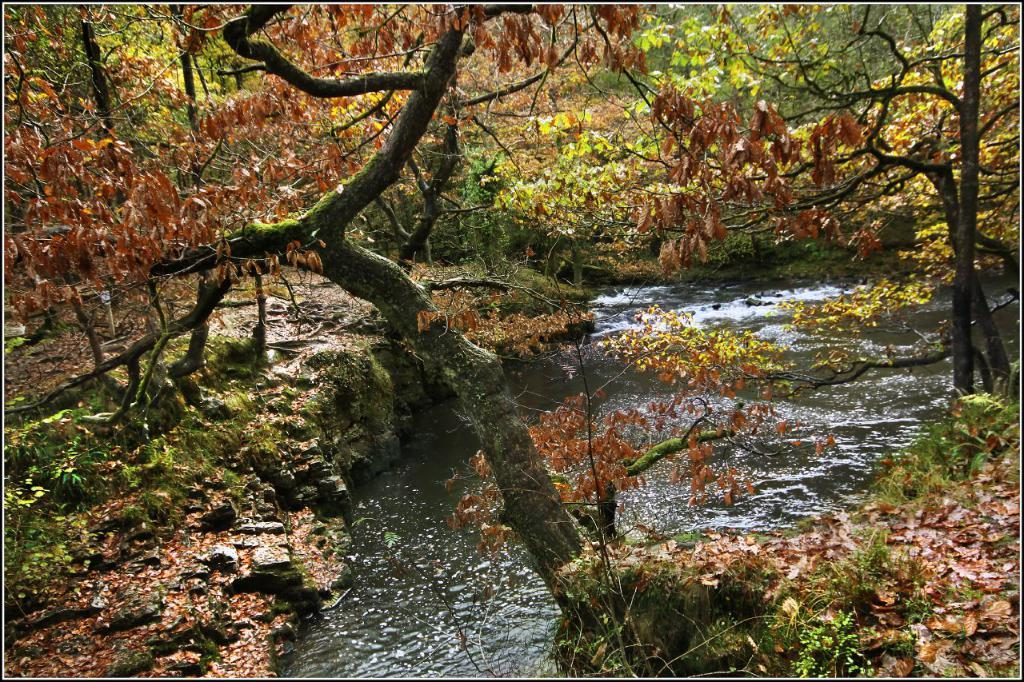What is happening in the image? There is water flowing in the image. What type of vegetation can be seen in the image? Plants and trees are present in the image. What is the income level of the spoon in the image? There is no spoon present in the image, so it is not possible to determine its income level. 